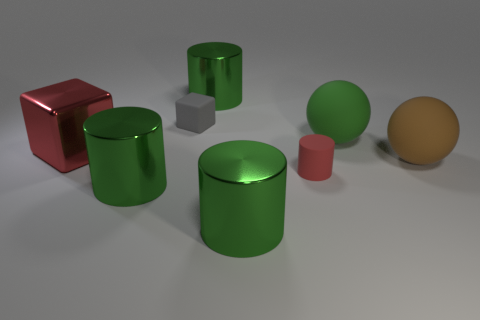What time of day or lighting environment might the scene represent? The scene looks like it could be set in an interior environment under artificial lighting. The consistent and soft shadows suggest a single light source, such as an overhead lamp, that could emulate an indoor setting at any time of day. 